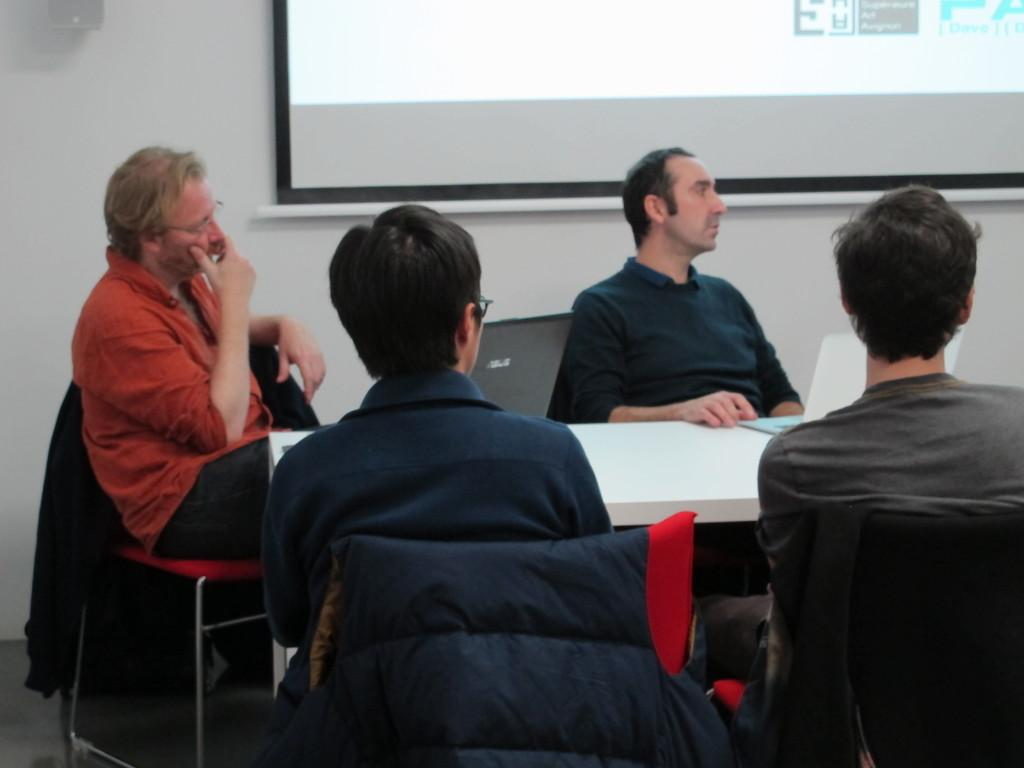How many people are in the image? There is a group of people in the image. What are the people doing in the image? The people are sitting in chairs. What is in front of the people? There is a table in front of the people. What can be seen on the table? Laptops are present on the table. What is visible in the background of the image? There is a projected image visible in the image. How many girls are present in the image? The provided facts do not mention the gender of the people in the image, so it cannot be determined if there are any girls present. What type of mice can be seen interacting with the laptops in the image? There are no mice present in the image; the laptops are not interacting with any animals. 